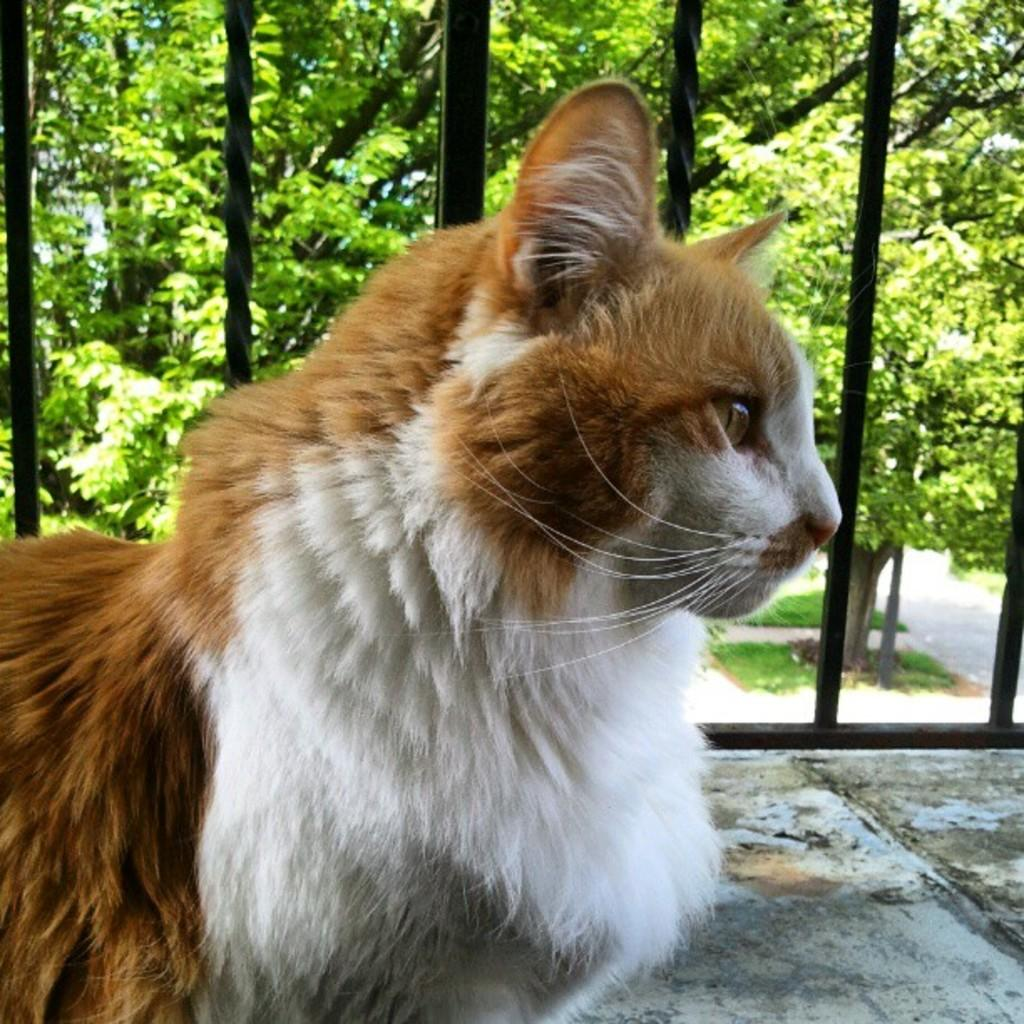What type of animal is present in the image? There is a cat in the image. What can be seen in the background of the image? There are a lot of trees in the background of the image. What type of grass is growing on the road in the image? There is no road or grass present in the image; it features a cat and trees in the background. 